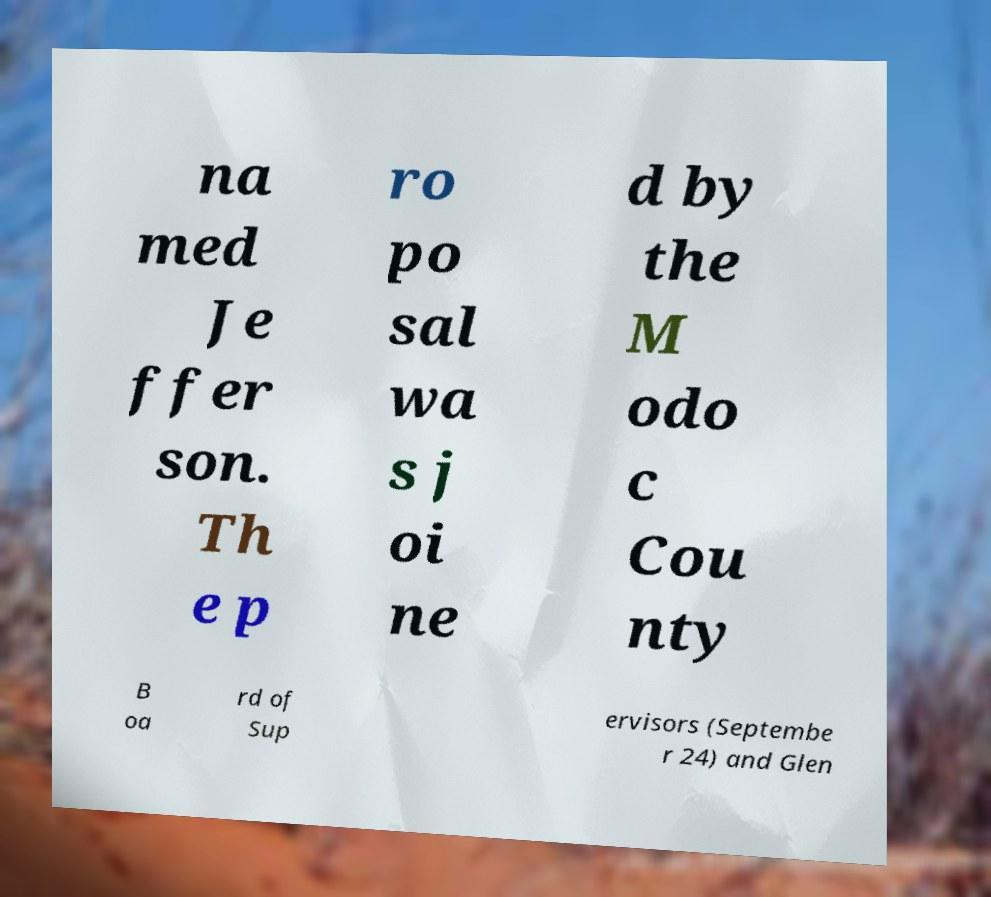For documentation purposes, I need the text within this image transcribed. Could you provide that? na med Je ffer son. Th e p ro po sal wa s j oi ne d by the M odo c Cou nty B oa rd of Sup ervisors (Septembe r 24) and Glen 